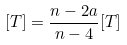<formula> <loc_0><loc_0><loc_500><loc_500>[ T ] = \frac { n - 2 a } { n - 4 } [ T ]</formula> 